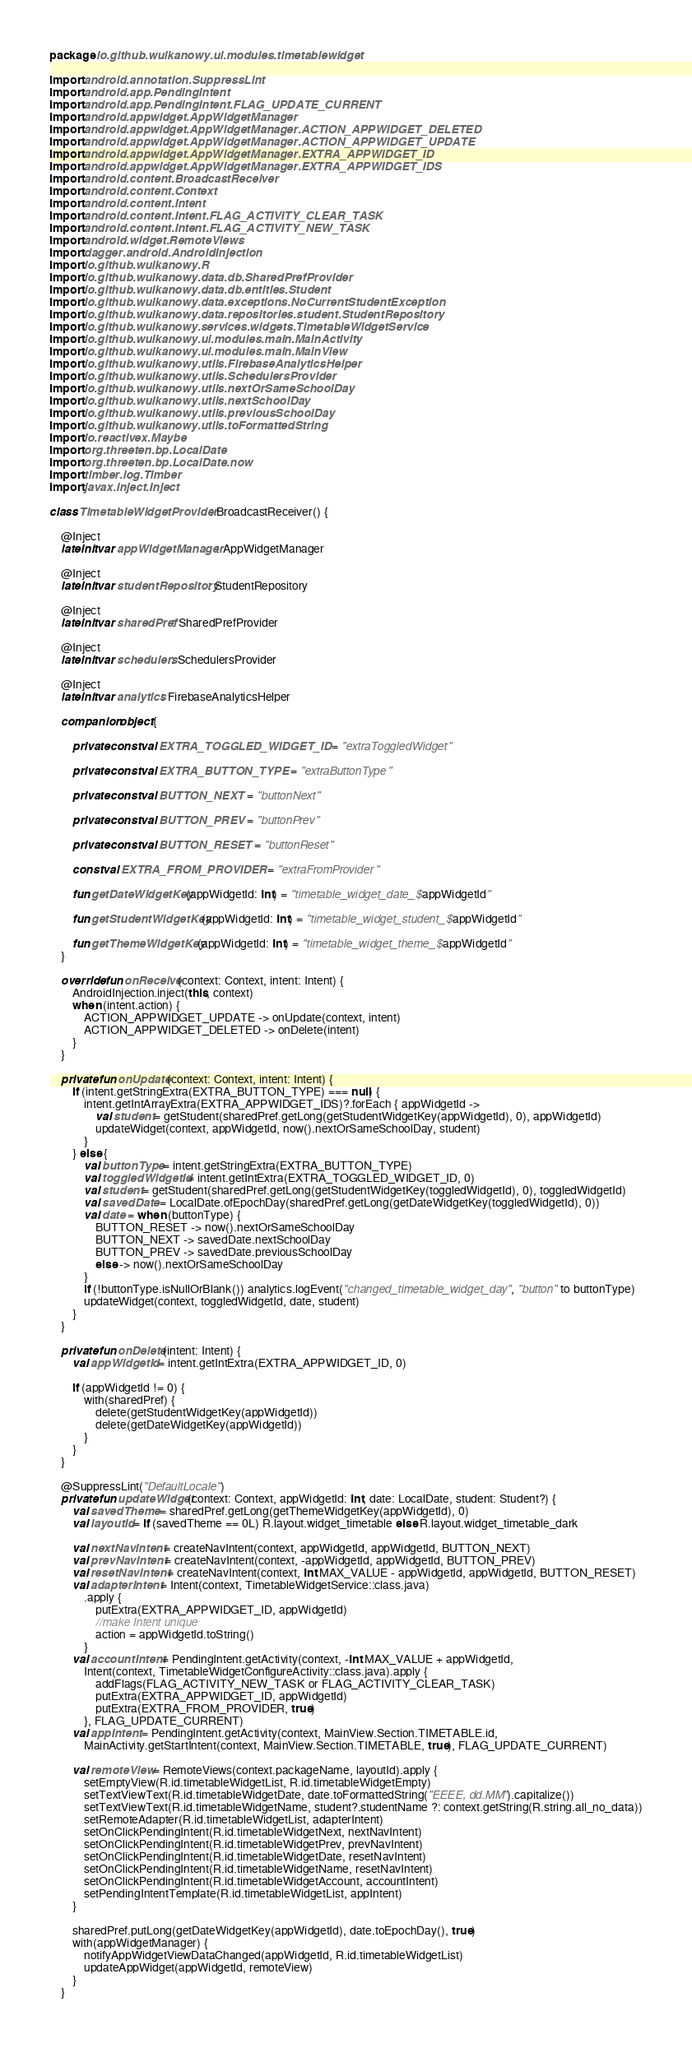<code> <loc_0><loc_0><loc_500><loc_500><_Kotlin_>package io.github.wulkanowy.ui.modules.timetablewidget

import android.annotation.SuppressLint
import android.app.PendingIntent
import android.app.PendingIntent.FLAG_UPDATE_CURRENT
import android.appwidget.AppWidgetManager
import android.appwidget.AppWidgetManager.ACTION_APPWIDGET_DELETED
import android.appwidget.AppWidgetManager.ACTION_APPWIDGET_UPDATE
import android.appwidget.AppWidgetManager.EXTRA_APPWIDGET_ID
import android.appwidget.AppWidgetManager.EXTRA_APPWIDGET_IDS
import android.content.BroadcastReceiver
import android.content.Context
import android.content.Intent
import android.content.Intent.FLAG_ACTIVITY_CLEAR_TASK
import android.content.Intent.FLAG_ACTIVITY_NEW_TASK
import android.widget.RemoteViews
import dagger.android.AndroidInjection
import io.github.wulkanowy.R
import io.github.wulkanowy.data.db.SharedPrefProvider
import io.github.wulkanowy.data.db.entities.Student
import io.github.wulkanowy.data.exceptions.NoCurrentStudentException
import io.github.wulkanowy.data.repositories.student.StudentRepository
import io.github.wulkanowy.services.widgets.TimetableWidgetService
import io.github.wulkanowy.ui.modules.main.MainActivity
import io.github.wulkanowy.ui.modules.main.MainView
import io.github.wulkanowy.utils.FirebaseAnalyticsHelper
import io.github.wulkanowy.utils.SchedulersProvider
import io.github.wulkanowy.utils.nextOrSameSchoolDay
import io.github.wulkanowy.utils.nextSchoolDay
import io.github.wulkanowy.utils.previousSchoolDay
import io.github.wulkanowy.utils.toFormattedString
import io.reactivex.Maybe
import org.threeten.bp.LocalDate
import org.threeten.bp.LocalDate.now
import timber.log.Timber
import javax.inject.Inject

class TimetableWidgetProvider : BroadcastReceiver() {

    @Inject
    lateinit var appWidgetManager: AppWidgetManager

    @Inject
    lateinit var studentRepository: StudentRepository

    @Inject
    lateinit var sharedPref: SharedPrefProvider

    @Inject
    lateinit var schedulers: SchedulersProvider

    @Inject
    lateinit var analytics: FirebaseAnalyticsHelper

    companion object {

        private const val EXTRA_TOGGLED_WIDGET_ID = "extraToggledWidget"

        private const val EXTRA_BUTTON_TYPE = "extraButtonType"

        private const val BUTTON_NEXT = "buttonNext"

        private const val BUTTON_PREV = "buttonPrev"

        private const val BUTTON_RESET = "buttonReset"

        const val EXTRA_FROM_PROVIDER = "extraFromProvider"

        fun getDateWidgetKey(appWidgetId: Int) = "timetable_widget_date_$appWidgetId"

        fun getStudentWidgetKey(appWidgetId: Int) = "timetable_widget_student_$appWidgetId"

        fun getThemeWidgetKey(appWidgetId: Int) = "timetable_widget_theme_$appWidgetId"
    }

    override fun onReceive(context: Context, intent: Intent) {
        AndroidInjection.inject(this, context)
        when (intent.action) {
            ACTION_APPWIDGET_UPDATE -> onUpdate(context, intent)
            ACTION_APPWIDGET_DELETED -> onDelete(intent)
        }
    }

    private fun onUpdate(context: Context, intent: Intent) {
        if (intent.getStringExtra(EXTRA_BUTTON_TYPE) === null) {
            intent.getIntArrayExtra(EXTRA_APPWIDGET_IDS)?.forEach { appWidgetId ->
                val student = getStudent(sharedPref.getLong(getStudentWidgetKey(appWidgetId), 0), appWidgetId)
                updateWidget(context, appWidgetId, now().nextOrSameSchoolDay, student)
            }
        } else {
            val buttonType = intent.getStringExtra(EXTRA_BUTTON_TYPE)
            val toggledWidgetId = intent.getIntExtra(EXTRA_TOGGLED_WIDGET_ID, 0)
            val student = getStudent(sharedPref.getLong(getStudentWidgetKey(toggledWidgetId), 0), toggledWidgetId)
            val savedDate = LocalDate.ofEpochDay(sharedPref.getLong(getDateWidgetKey(toggledWidgetId), 0))
            val date = when (buttonType) {
                BUTTON_RESET -> now().nextOrSameSchoolDay
                BUTTON_NEXT -> savedDate.nextSchoolDay
                BUTTON_PREV -> savedDate.previousSchoolDay
                else -> now().nextOrSameSchoolDay
            }
            if (!buttonType.isNullOrBlank()) analytics.logEvent("changed_timetable_widget_day", "button" to buttonType)
            updateWidget(context, toggledWidgetId, date, student)
        }
    }

    private fun onDelete(intent: Intent) {
        val appWidgetId = intent.getIntExtra(EXTRA_APPWIDGET_ID, 0)

        if (appWidgetId != 0) {
            with(sharedPref) {
                delete(getStudentWidgetKey(appWidgetId))
                delete(getDateWidgetKey(appWidgetId))
            }
        }
    }

    @SuppressLint("DefaultLocale")
    private fun updateWidget(context: Context, appWidgetId: Int, date: LocalDate, student: Student?) {
        val savedTheme = sharedPref.getLong(getThemeWidgetKey(appWidgetId), 0)
        val layoutId = if (savedTheme == 0L) R.layout.widget_timetable else R.layout.widget_timetable_dark

        val nextNavIntent = createNavIntent(context, appWidgetId, appWidgetId, BUTTON_NEXT)
        val prevNavIntent = createNavIntent(context, -appWidgetId, appWidgetId, BUTTON_PREV)
        val resetNavIntent = createNavIntent(context, Int.MAX_VALUE - appWidgetId, appWidgetId, BUTTON_RESET)
        val adapterIntent = Intent(context, TimetableWidgetService::class.java)
            .apply {
                putExtra(EXTRA_APPWIDGET_ID, appWidgetId)
                //make Intent unique
                action = appWidgetId.toString()
            }
        val accountIntent = PendingIntent.getActivity(context, -Int.MAX_VALUE + appWidgetId,
            Intent(context, TimetableWidgetConfigureActivity::class.java).apply {
                addFlags(FLAG_ACTIVITY_NEW_TASK or FLAG_ACTIVITY_CLEAR_TASK)
                putExtra(EXTRA_APPWIDGET_ID, appWidgetId)
                putExtra(EXTRA_FROM_PROVIDER, true)
            }, FLAG_UPDATE_CURRENT)
        val appIntent = PendingIntent.getActivity(context, MainView.Section.TIMETABLE.id,
            MainActivity.getStartIntent(context, MainView.Section.TIMETABLE, true), FLAG_UPDATE_CURRENT)

        val remoteView = RemoteViews(context.packageName, layoutId).apply {
            setEmptyView(R.id.timetableWidgetList, R.id.timetableWidgetEmpty)
            setTextViewText(R.id.timetableWidgetDate, date.toFormattedString("EEEE, dd.MM").capitalize())
            setTextViewText(R.id.timetableWidgetName, student?.studentName ?: context.getString(R.string.all_no_data))
            setRemoteAdapter(R.id.timetableWidgetList, adapterIntent)
            setOnClickPendingIntent(R.id.timetableWidgetNext, nextNavIntent)
            setOnClickPendingIntent(R.id.timetableWidgetPrev, prevNavIntent)
            setOnClickPendingIntent(R.id.timetableWidgetDate, resetNavIntent)
            setOnClickPendingIntent(R.id.timetableWidgetName, resetNavIntent)
            setOnClickPendingIntent(R.id.timetableWidgetAccount, accountIntent)
            setPendingIntentTemplate(R.id.timetableWidgetList, appIntent)
        }

        sharedPref.putLong(getDateWidgetKey(appWidgetId), date.toEpochDay(), true)
        with(appWidgetManager) {
            notifyAppWidgetViewDataChanged(appWidgetId, R.id.timetableWidgetList)
            updateAppWidget(appWidgetId, remoteView)
        }
    }
</code> 